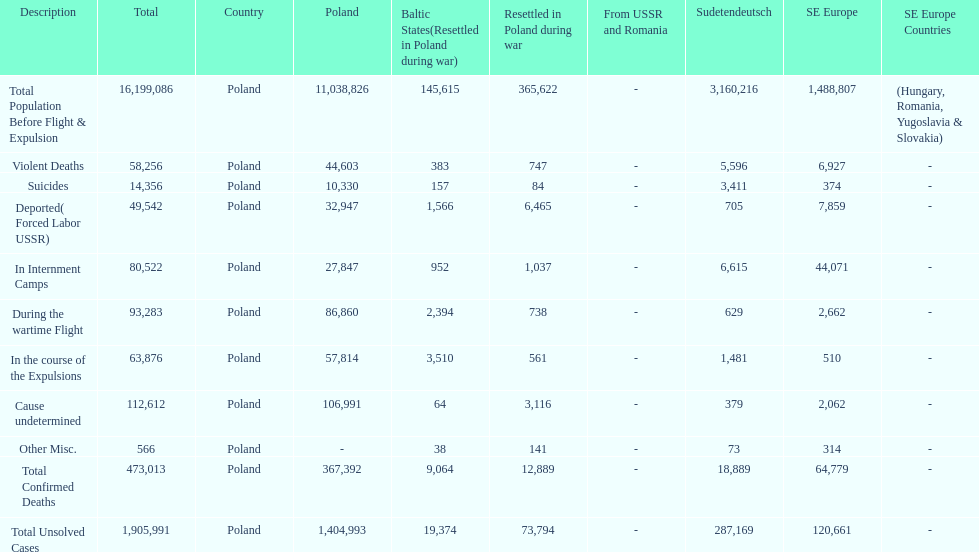How many causes were responsible for more than 50,000 confirmed deaths? 5. Parse the full table. {'header': ['Description', 'Total', 'Country', 'Poland', 'Baltic States(Resettled in Poland during war)', 'Resettled in Poland during war', 'From USSR and Romania', 'Sudetendeutsch', 'SE Europe', 'SE Europe Countries'], 'rows': [['Total Population Before Flight & Expulsion', '16,199,086', 'Poland', '11,038,826', '145,615', '365,622', '-', '3,160,216', '1,488,807', '(Hungary, Romania, Yugoslavia & Slovakia)'], ['Violent Deaths', '58,256', 'Poland', '44,603', '383', '747', '-', '5,596', '6,927', '-'], ['Suicides', '14,356', 'Poland', '10,330', '157', '84', '-', '3,411', '374', '-'], ['Deported( Forced Labor USSR)', '49,542', 'Poland', '32,947', '1,566', '6,465', '-', '705', '7,859', '-'], ['In Internment Camps', '80,522', 'Poland', '27,847', '952', '1,037', '-', '6,615', '44,071', '-'], ['During the wartime Flight', '93,283', 'Poland', '86,860', '2,394', '738', '-', '629', '2,662', '-'], ['In the course of the Expulsions', '63,876', 'Poland', '57,814', '3,510', '561', '-', '1,481', '510', '-'], ['Cause undetermined', '112,612', 'Poland', '106,991', '64', '3,116', '-', '379', '2,062', '-'], ['Other Misc.', '566', 'Poland', '-', '38', '141', '-', '73', '314', '-'], ['Total Confirmed Deaths', '473,013', 'Poland', '367,392', '9,064', '12,889', '-', '18,889', '64,779', '-'], ['Total Unsolved Cases', '1,905,991', 'Poland', '1,404,993', '19,374', '73,794', '-', '287,169', '120,661', '-']]} 